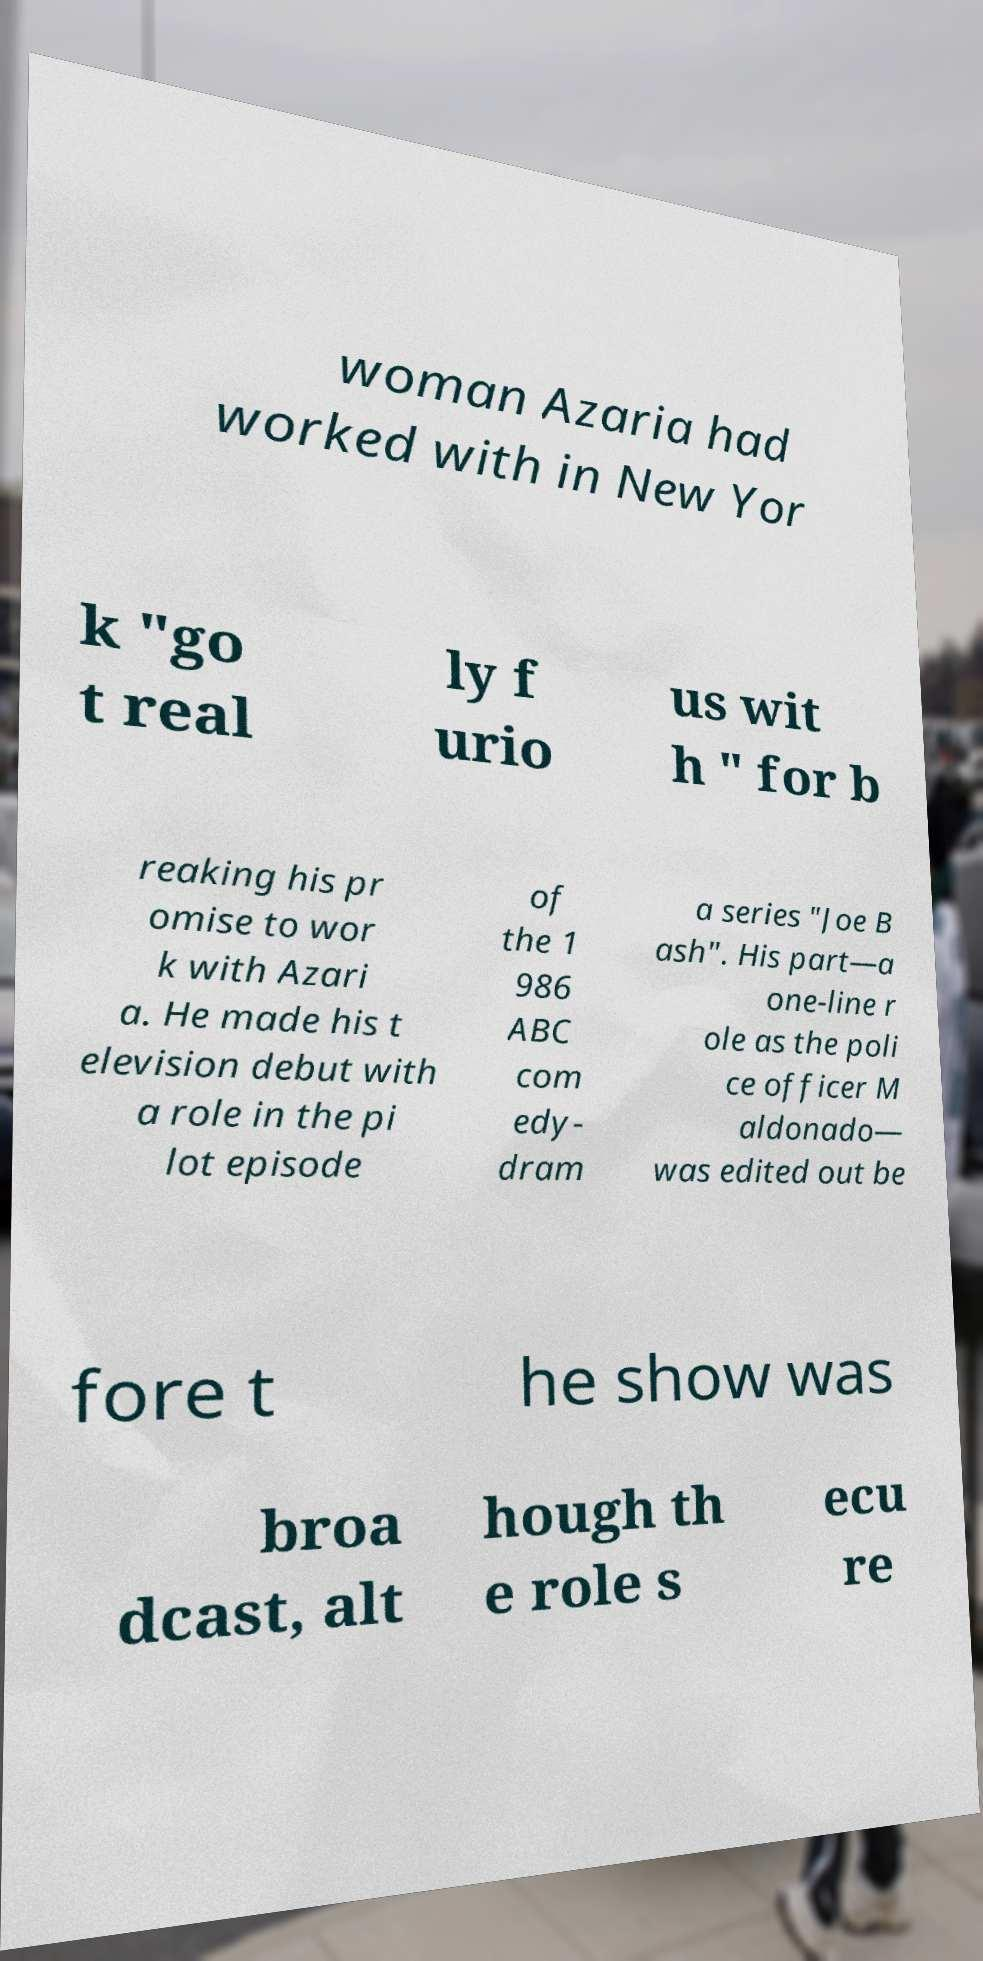Can you accurately transcribe the text from the provided image for me? woman Azaria had worked with in New Yor k "go t real ly f urio us wit h " for b reaking his pr omise to wor k with Azari a. He made his t elevision debut with a role in the pi lot episode of the 1 986 ABC com edy- dram a series "Joe B ash". His part—a one-line r ole as the poli ce officer M aldonado— was edited out be fore t he show was broa dcast, alt hough th e role s ecu re 